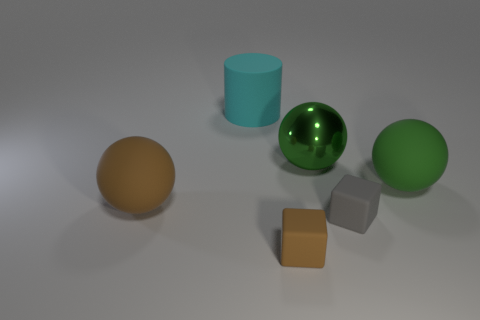Subtract all yellow blocks. How many green balls are left? 2 Subtract all brown spheres. How many spheres are left? 2 Add 3 tiny rubber blocks. How many objects exist? 9 Subtract 1 spheres. How many spheres are left? 2 Subtract all cylinders. How many objects are left? 5 Subtract all cyan spheres. Subtract all red cylinders. How many spheres are left? 3 Add 4 big purple rubber things. How many big purple rubber things exist? 4 Subtract 0 red blocks. How many objects are left? 6 Subtract all small green things. Subtract all big green metallic balls. How many objects are left? 5 Add 4 brown rubber blocks. How many brown rubber blocks are left? 5 